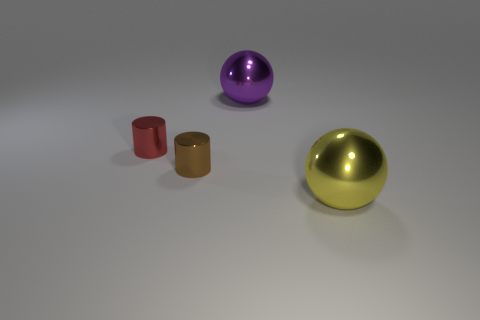Add 1 metallic things. How many objects exist? 5 Subtract all big yellow metal objects. Subtract all small things. How many objects are left? 1 Add 1 big metallic spheres. How many big metallic spheres are left? 3 Add 2 purple metallic things. How many purple metallic things exist? 3 Subtract 1 purple balls. How many objects are left? 3 Subtract all red balls. Subtract all gray blocks. How many balls are left? 2 